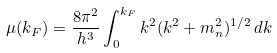Convert formula to latex. <formula><loc_0><loc_0><loc_500><loc_500>\mu ( k _ { F } ) = \frac { 8 \pi ^ { 2 } } { h ^ { 3 } } \int _ { 0 } ^ { k _ { F } } k ^ { 2 } ( k ^ { 2 } + m _ { n } ^ { 2 } ) ^ { 1 / 2 } \, d k</formula> 